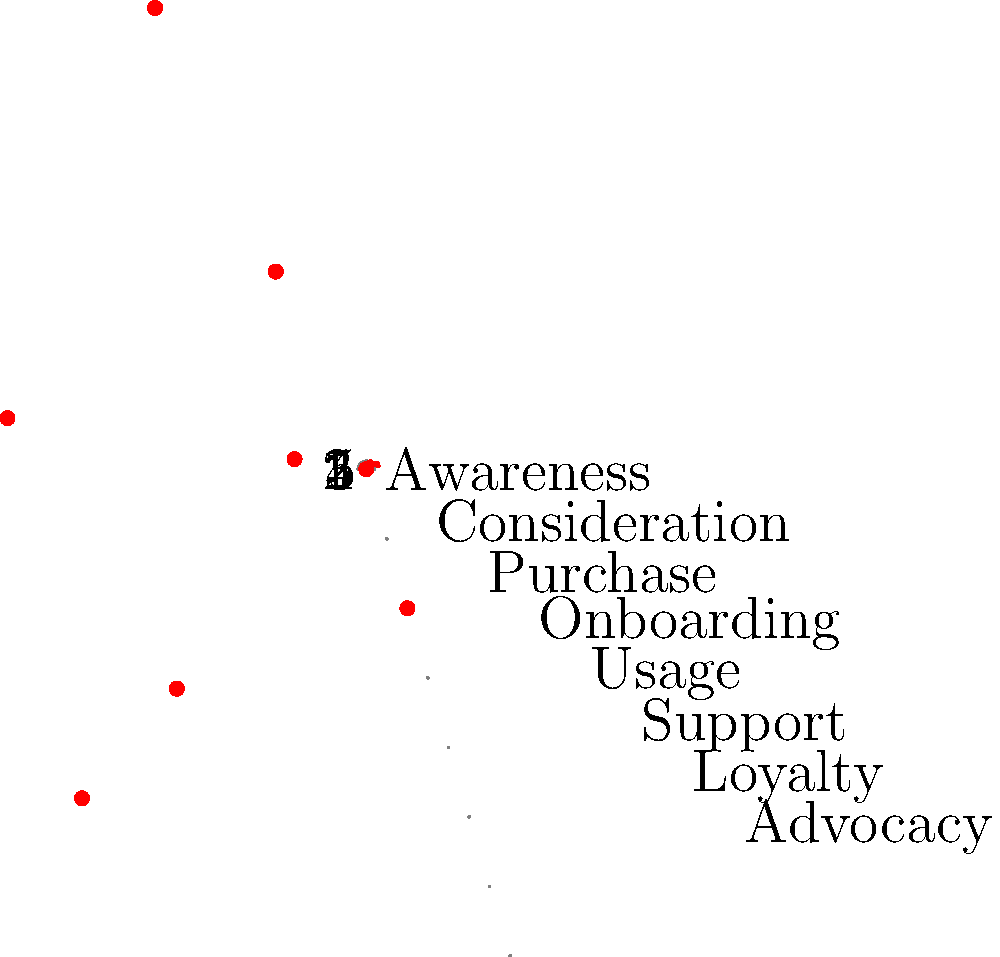Based on the polar coordinate graph representing a user journey map, which two touchpoints show the lowest satisfaction ratings, and what strategic action might a product designer take to address these pain points? To answer this question, we need to analyze the polar coordinate graph and follow these steps:

1. Identify the touchpoints: The graph shows 8 touchpoints in the user journey: Awareness, Consideration, Purchase, Onboarding, Usage, Support, Loyalty, and Advocacy.

2. Interpret the ratings: The concentric circles represent satisfaction ratings from 1 (innermost) to 5 (outermost).

3. Locate the lowest ratings: By examining the red dots on the graph, we can see that:
   - Onboarding has a rating of 2
   - Advocacy has a rating of 2
   These are the lowest ratings among all touchpoints.

4. Strategic action: As an experienced product designer, a strategic action to address these pain points could be:
   - For Onboarding: Implement a more intuitive and user-friendly onboarding process, possibly including interactive tutorials or a step-by-step guide to help new users understand the product's features and benefits more easily.
   - For Advocacy: Develop a loyalty program or referral system that incentivizes satisfied customers to become brand advocates, potentially offering rewards or exclusive benefits for those who actively promote the product.

5. Rationale: Improving these two touchpoints can have a significant impact on the overall user experience and business growth:
   - A better onboarding experience can reduce user churn and increase long-term engagement.
   - Enhancing advocacy can lead to organic growth through word-of-mouth marketing and increased customer loyalty.
Answer: Onboarding and Advocacy; Improve onboarding process and implement loyalty program 